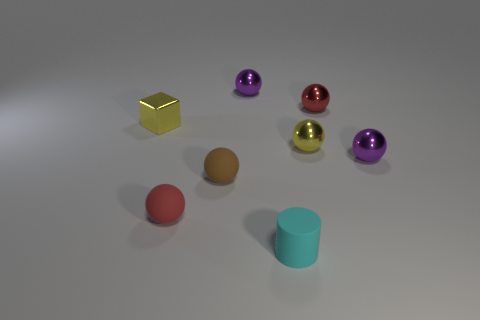Do the cube and the cyan cylinder that is in front of the tiny red shiny sphere have the same size?
Provide a short and direct response. Yes. What number of big things are either cubes or green metallic objects?
Keep it short and to the point. 0. The brown object has what shape?
Keep it short and to the point. Sphere. Are there any big brown things that have the same material as the small cube?
Provide a succinct answer. No. Are there more purple spheres than small blocks?
Your answer should be very brief. Yes. Are the cube and the brown sphere made of the same material?
Offer a terse response. No. What number of shiny objects are either gray cylinders or yellow spheres?
Your response must be concise. 1. The metal block that is the same size as the cylinder is what color?
Keep it short and to the point. Yellow. What number of small purple shiny objects have the same shape as the red matte object?
Offer a terse response. 2. What number of cubes are either green shiny objects or metallic objects?
Offer a very short reply. 1. 